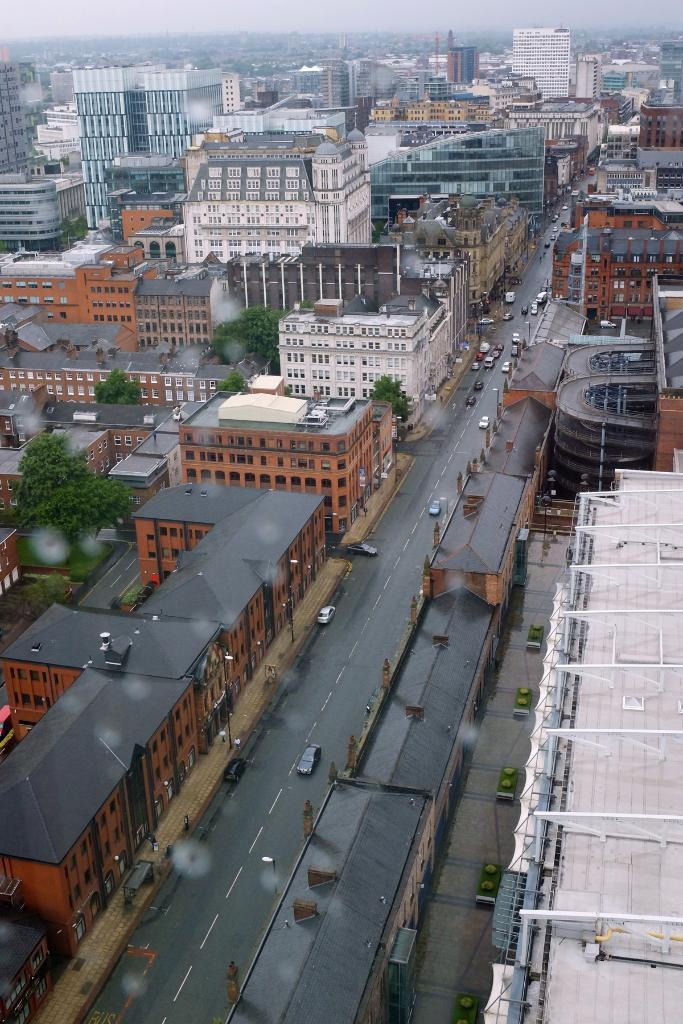What type of structures can be seen in the image? There are many buildings in the image. What else can be seen on the ground in the image? Vehicles are present on the road in the image. What type of natural elements are visible in the image? Trees are visible in the image. What part of the buildings can be seen in the image? Roofs are observable in the image. What type of scarecrow can be seen in the image? There is no scarecrow present in the image. What effect does the image have on the viewer's hearing? The image is silent and does not have any effect on the viewer's hearing. 